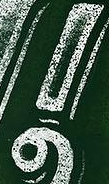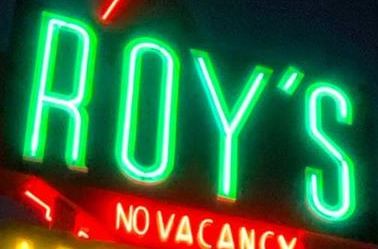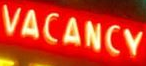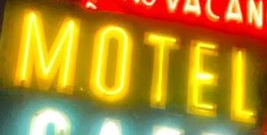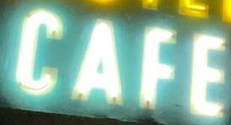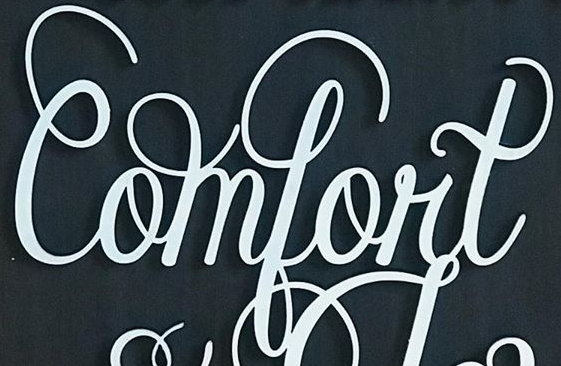Read the text from these images in sequence, separated by a semicolon. !; ROY'S; VACANCY; MOTEL; CAFE; Comfort 